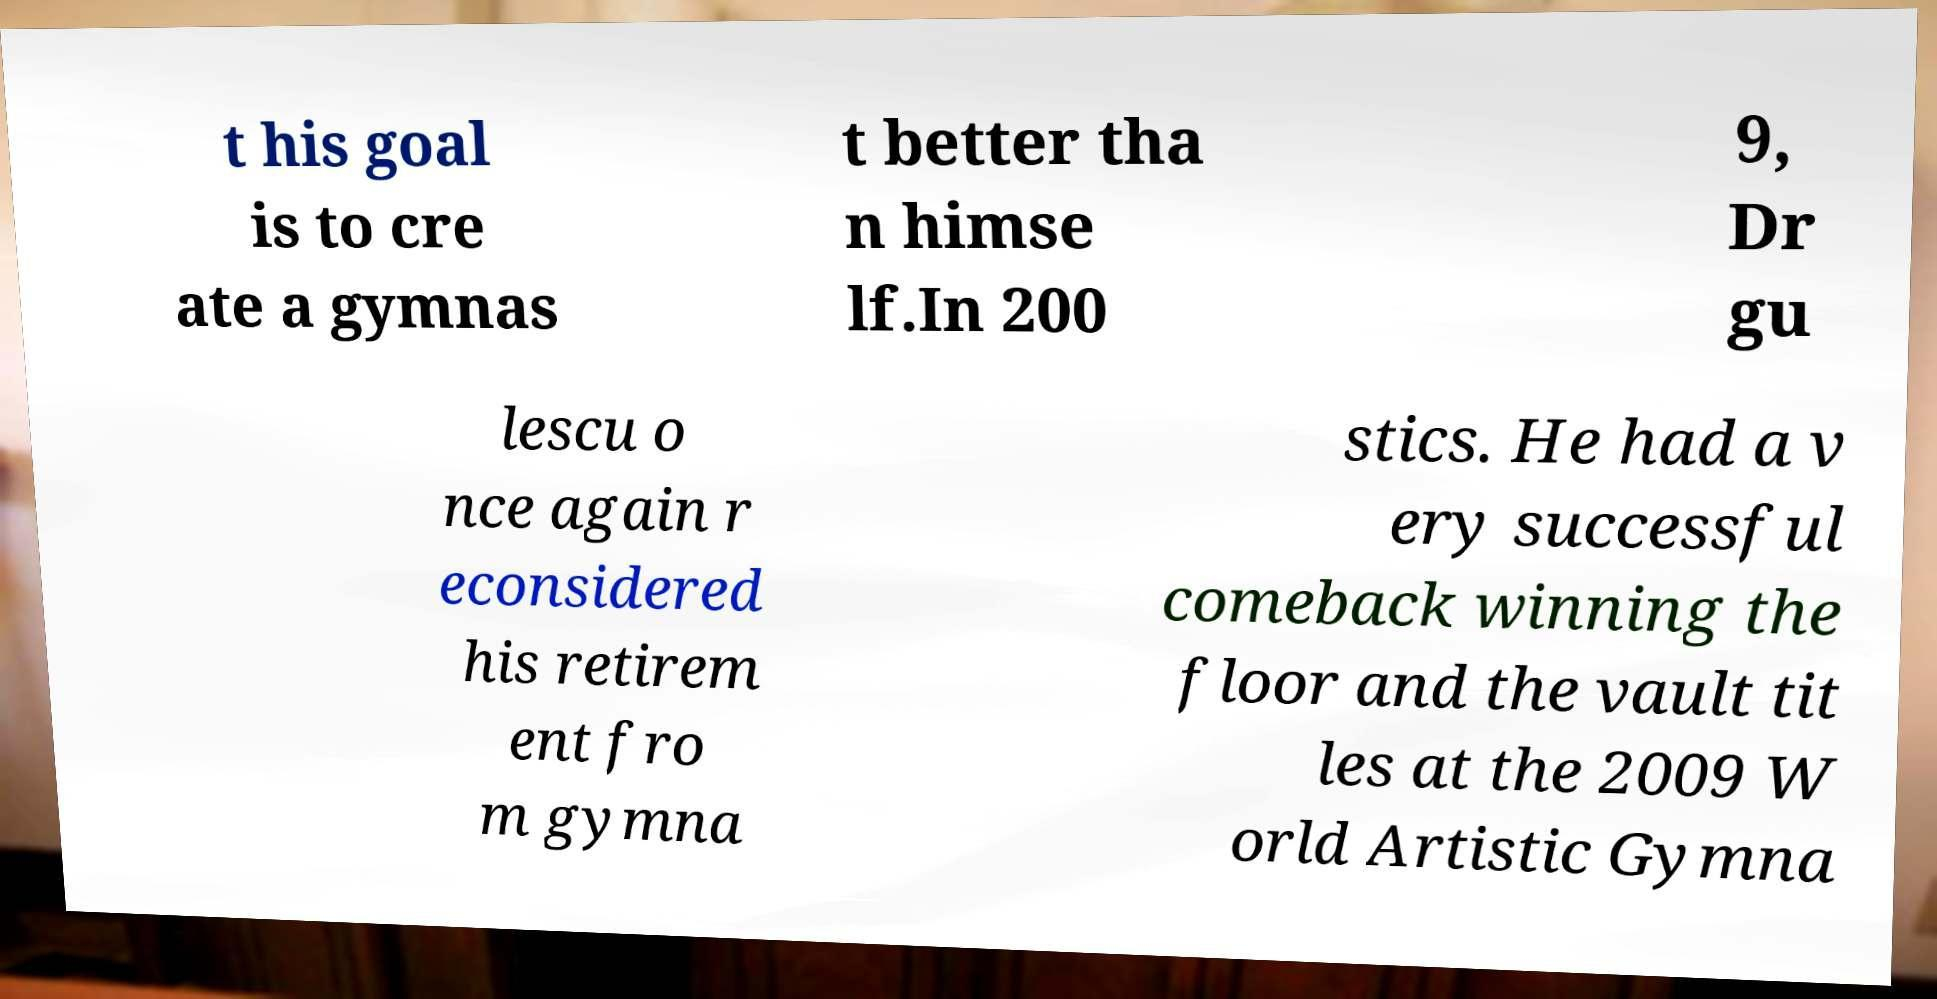Can you accurately transcribe the text from the provided image for me? t his goal is to cre ate a gymnas t better tha n himse lf.In 200 9, Dr gu lescu o nce again r econsidered his retirem ent fro m gymna stics. He had a v ery successful comeback winning the floor and the vault tit les at the 2009 W orld Artistic Gymna 